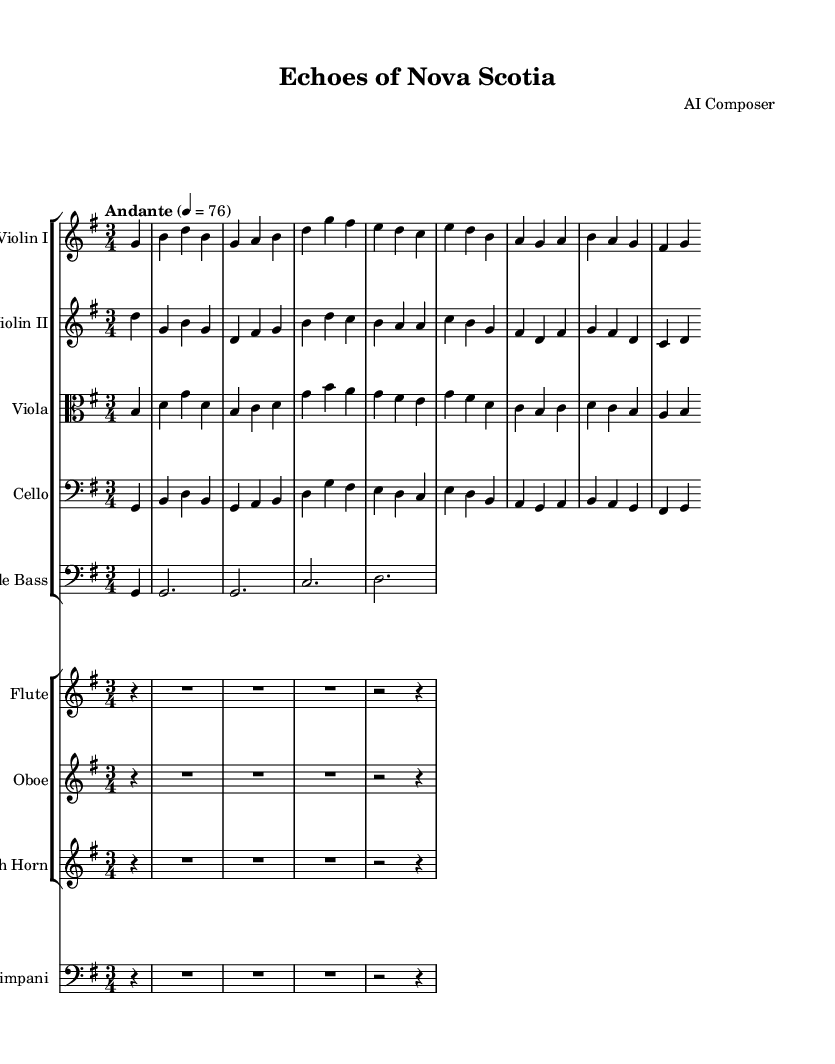What is the key signature of this music? The key signature is G major, which has one sharp indicating the note F#.
Answer: G major What is the time signature of this music? The time signature shown is 3/4, indicating three beats per measure, with the quarter note getting the beat.
Answer: 3/4 What is the tempo marking used in this piece? The tempo marking indicates "Andante," suggesting a moderately slow tempo.
Answer: Andante How many measures are in the first violin part? The first violin part has 8 measures, as counted visually from the beginning to the end of the line.
Answer: 8 measures Which instruments are playing the melody in this composition? The primary melody is carried by the first violin, supported by the flute and oboe in a softer role.
Answer: Violin I, Flute, Oboe What can be inferred about the mood of the piece based on the tempo and key? The piece has a reflective and gentle mood, as G major and Andante create a peaceful atmosphere, often evoking natural landscapes.
Answer: Reflective and gentle Which instrument is responsible for the bass line in this composition? The double bass typically provides the foundational bass line, anchoring the harmonic framework of the piece.
Answer: Double Bass 